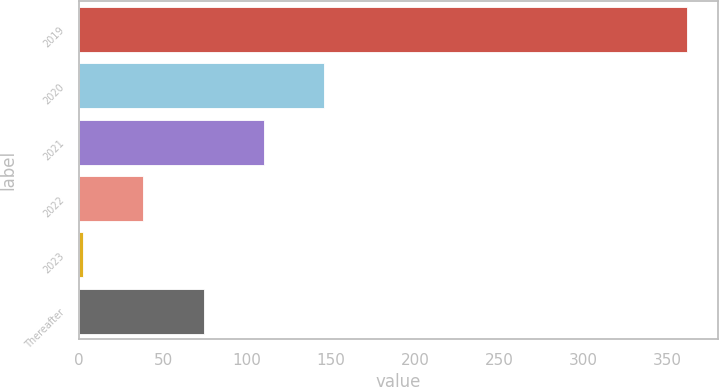Convert chart. <chart><loc_0><loc_0><loc_500><loc_500><bar_chart><fcel>2019<fcel>2020<fcel>2021<fcel>2022<fcel>2023<fcel>Thereafter<nl><fcel>362<fcel>146<fcel>110<fcel>38<fcel>2<fcel>74<nl></chart> 